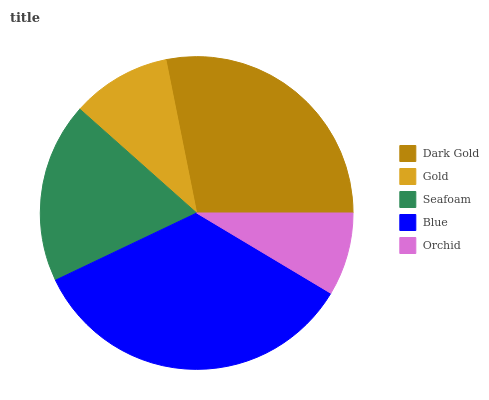Is Orchid the minimum?
Answer yes or no. Yes. Is Blue the maximum?
Answer yes or no. Yes. Is Gold the minimum?
Answer yes or no. No. Is Gold the maximum?
Answer yes or no. No. Is Dark Gold greater than Gold?
Answer yes or no. Yes. Is Gold less than Dark Gold?
Answer yes or no. Yes. Is Gold greater than Dark Gold?
Answer yes or no. No. Is Dark Gold less than Gold?
Answer yes or no. No. Is Seafoam the high median?
Answer yes or no. Yes. Is Seafoam the low median?
Answer yes or no. Yes. Is Dark Gold the high median?
Answer yes or no. No. Is Dark Gold the low median?
Answer yes or no. No. 